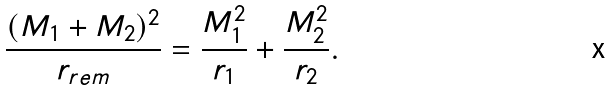<formula> <loc_0><loc_0><loc_500><loc_500>\frac { ( M _ { 1 } + M _ { 2 } ) ^ { 2 } } { r _ { r e m } } = \frac { M _ { 1 } ^ { 2 } } { r _ { 1 } } + \frac { M _ { 2 } ^ { 2 } } { r _ { 2 } } .</formula> 